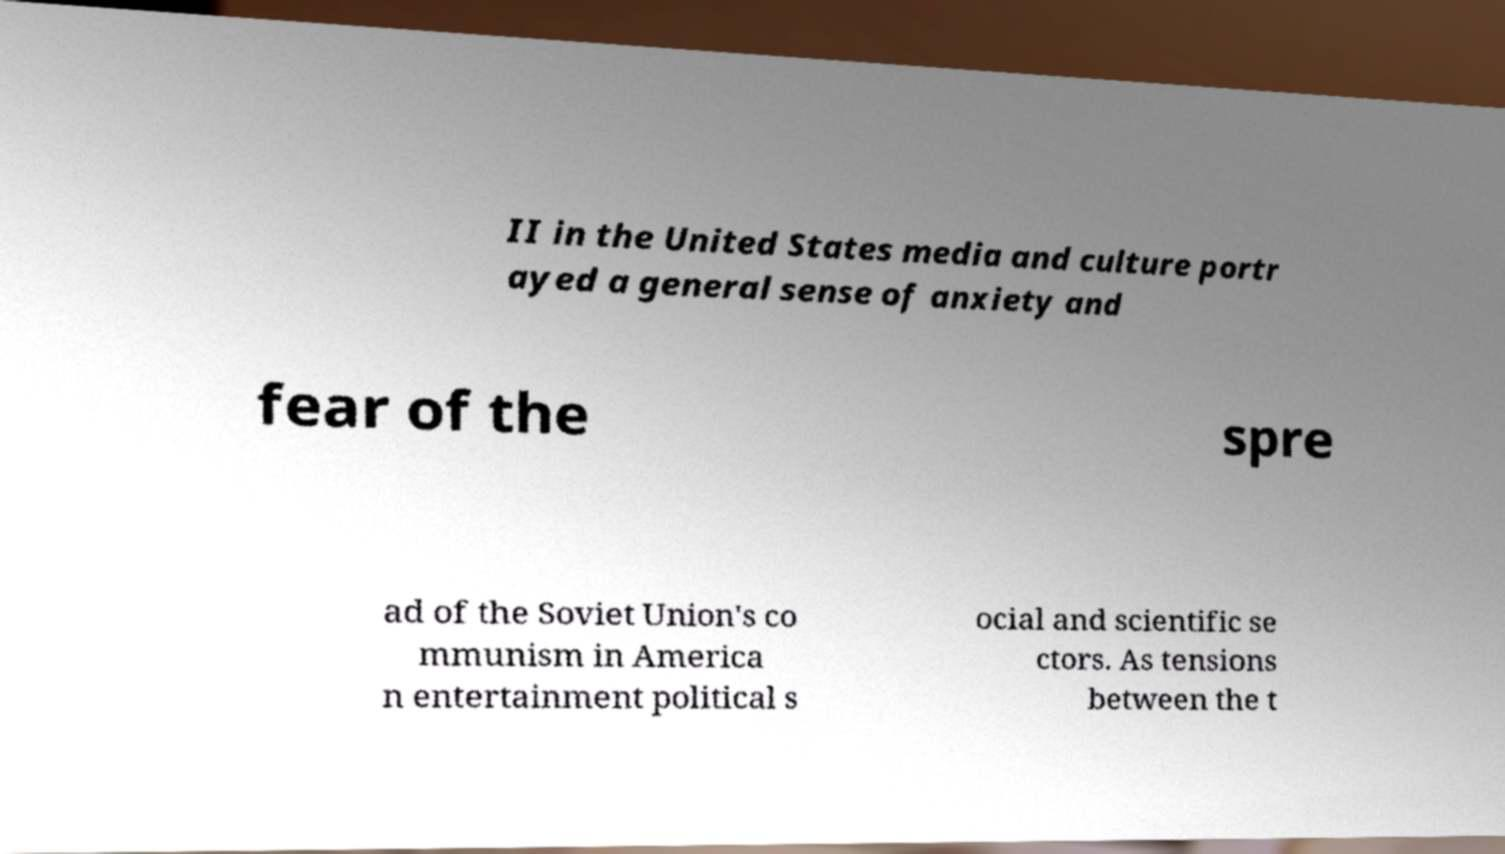There's text embedded in this image that I need extracted. Can you transcribe it verbatim? II in the United States media and culture portr ayed a general sense of anxiety and fear of the spre ad of the Soviet Union's co mmunism in America n entertainment political s ocial and scientific se ctors. As tensions between the t 